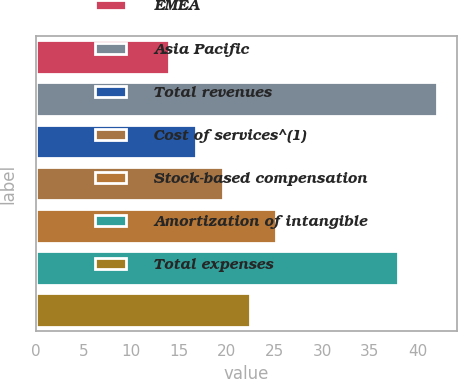Convert chart. <chart><loc_0><loc_0><loc_500><loc_500><bar_chart><fcel>EMEA<fcel>Asia Pacific<fcel>Total revenues<fcel>Cost of services^(1)<fcel>Stock-based compensation<fcel>Amortization of intangible<fcel>Total expenses<nl><fcel>14<fcel>42<fcel>16.8<fcel>19.6<fcel>25.2<fcel>38<fcel>22.4<nl></chart> 